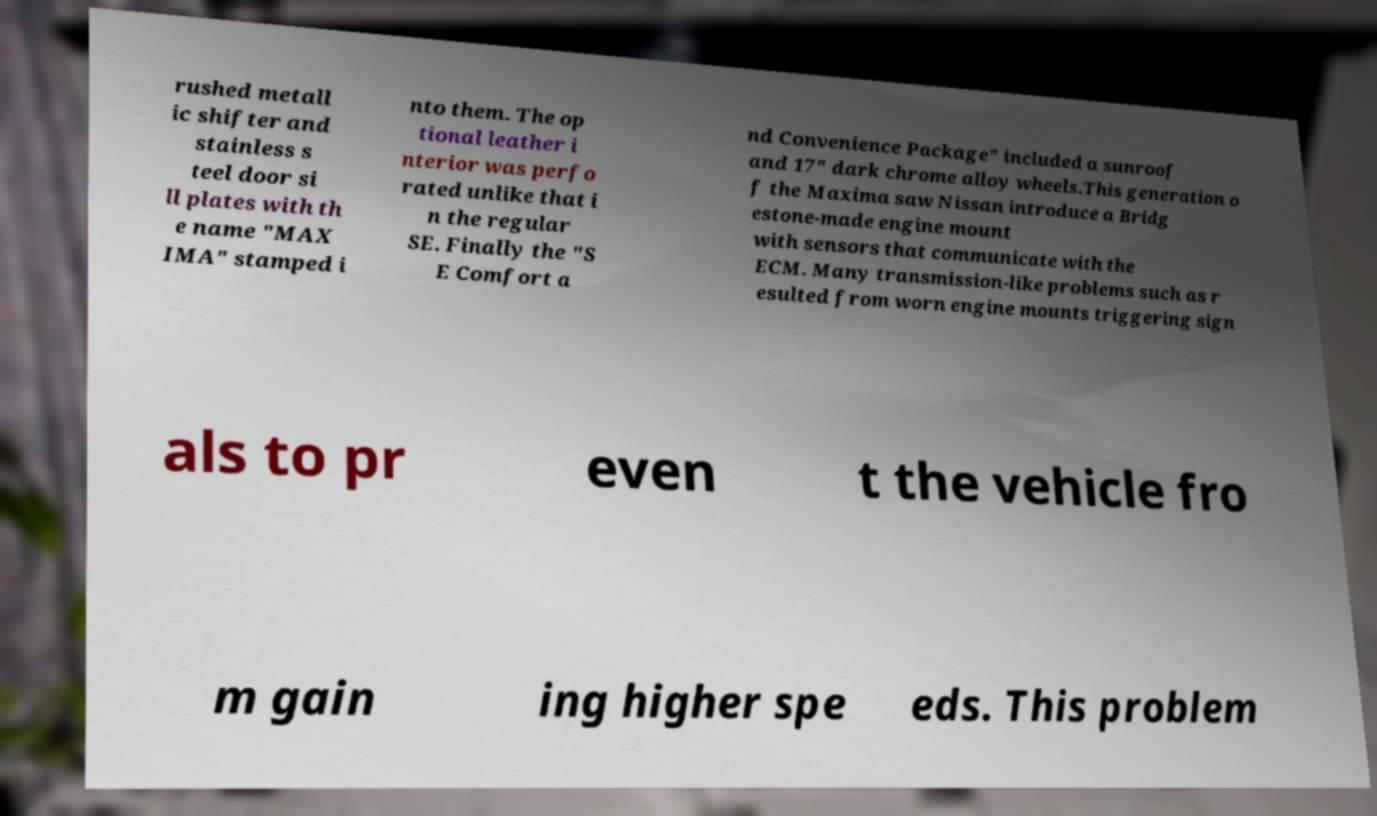Could you assist in decoding the text presented in this image and type it out clearly? rushed metall ic shifter and stainless s teel door si ll plates with th e name "MAX IMA" stamped i nto them. The op tional leather i nterior was perfo rated unlike that i n the regular SE. Finally the "S E Comfort a nd Convenience Package" included a sunroof and 17" dark chrome alloy wheels.This generation o f the Maxima saw Nissan introduce a Bridg estone-made engine mount with sensors that communicate with the ECM. Many transmission-like problems such as r esulted from worn engine mounts triggering sign als to pr even t the vehicle fro m gain ing higher spe eds. This problem 